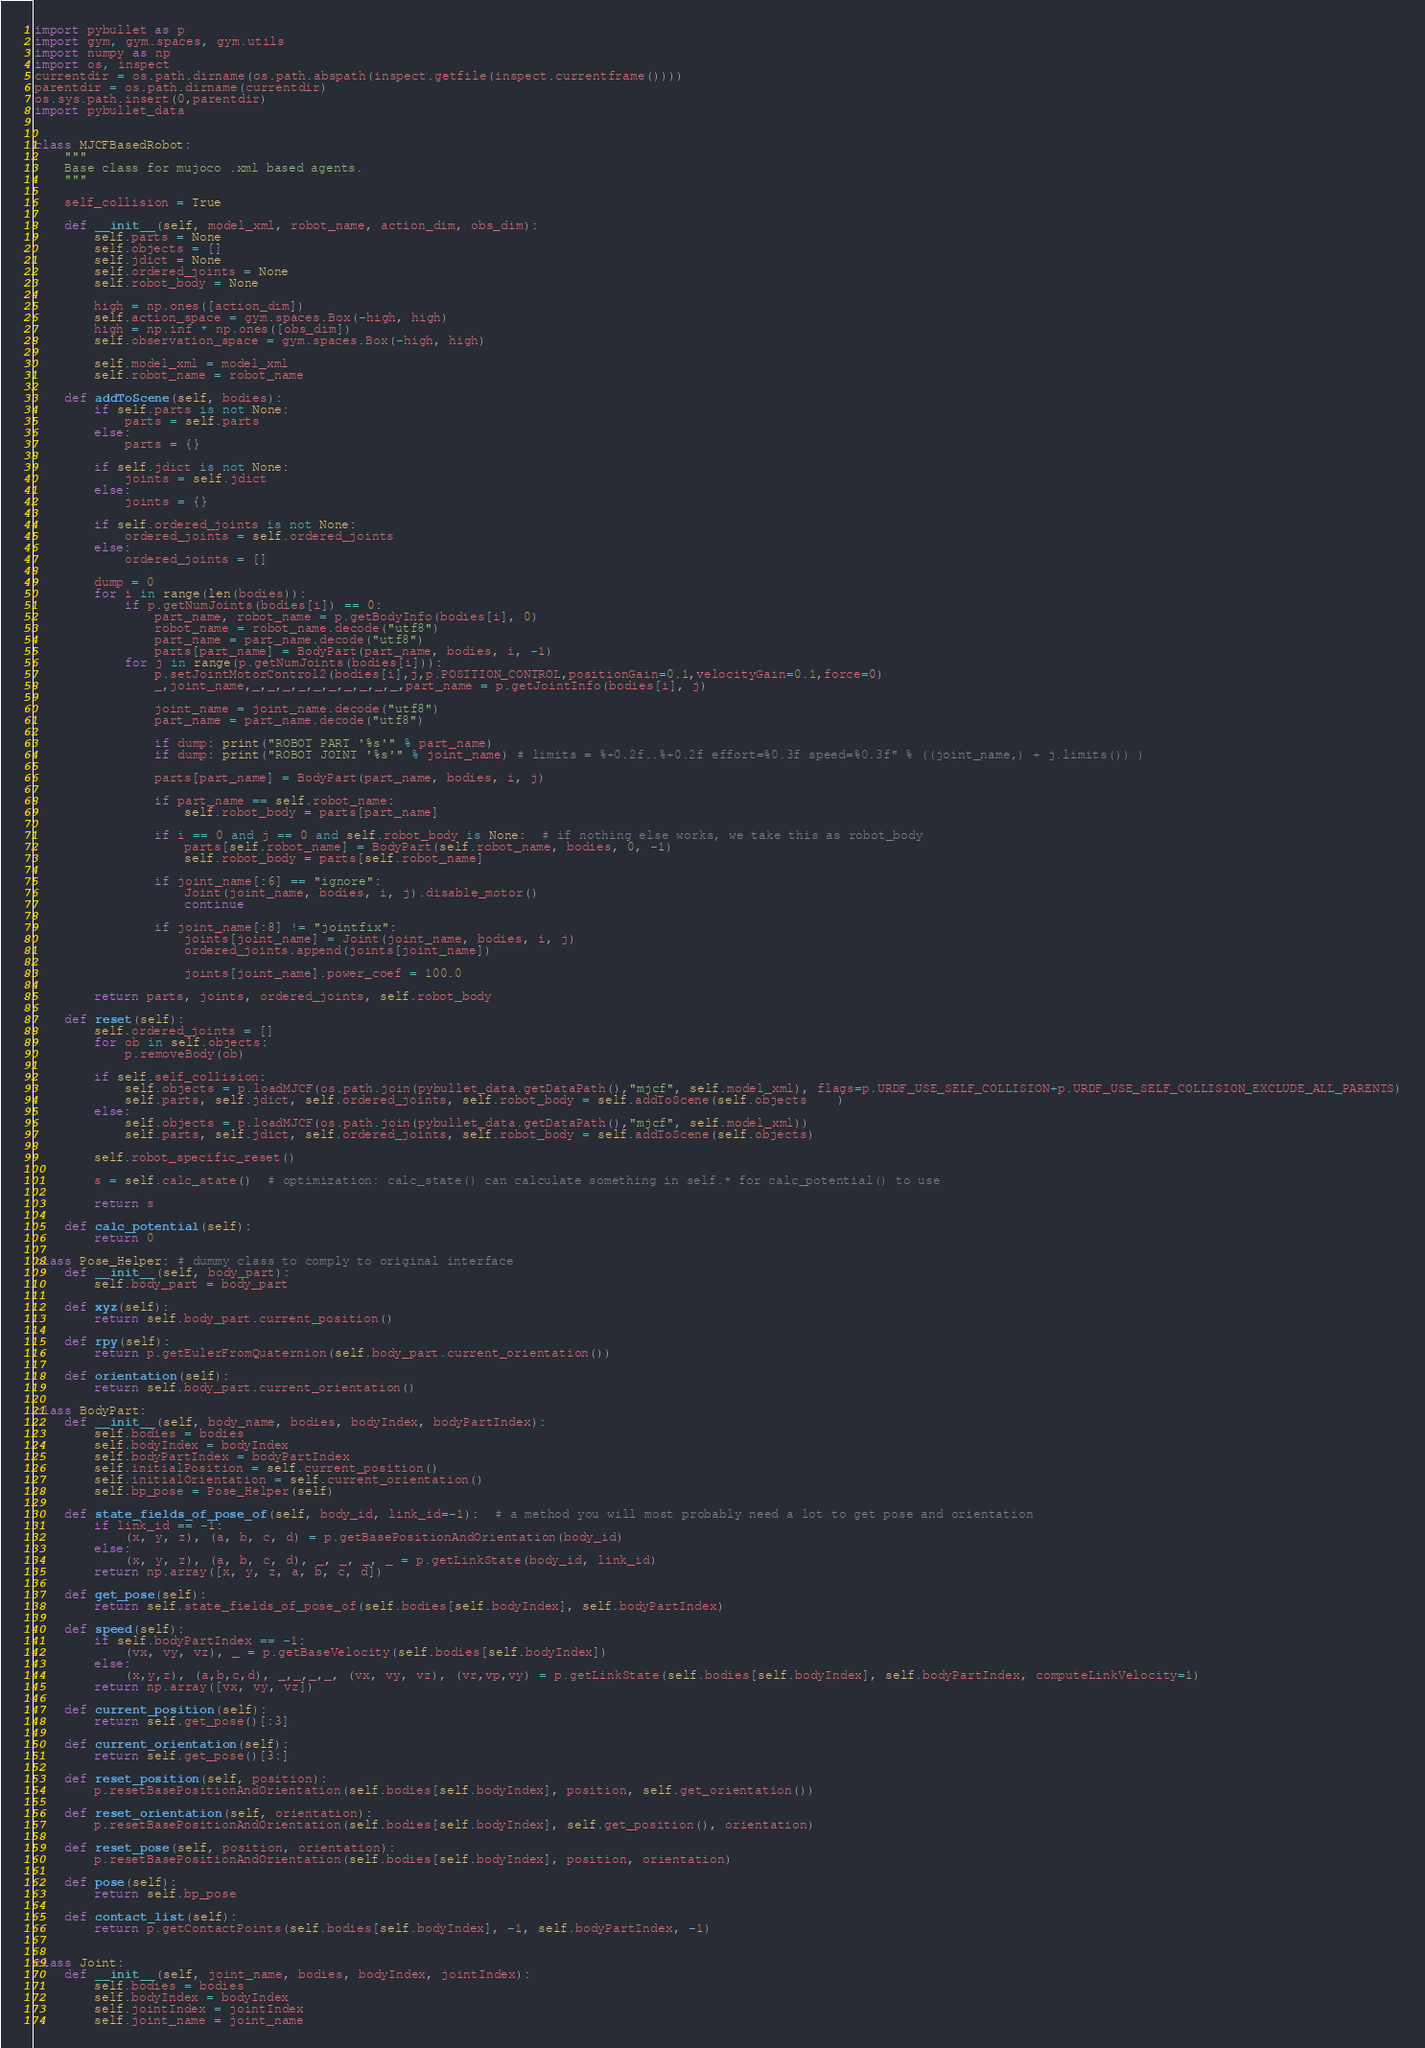Convert code to text. <code><loc_0><loc_0><loc_500><loc_500><_Python_>import pybullet as p
import gym, gym.spaces, gym.utils
import numpy as np
import os, inspect
currentdir = os.path.dirname(os.path.abspath(inspect.getfile(inspect.currentframe())))
parentdir = os.path.dirname(currentdir)
os.sys.path.insert(0,parentdir)
import pybullet_data


class MJCFBasedRobot:
	"""
	Base class for mujoco .xml based agents.
	"""

	self_collision = True

	def __init__(self, model_xml, robot_name, action_dim, obs_dim):
		self.parts = None
		self.objects = []
		self.jdict = None
		self.ordered_joints = None
		self.robot_body = None

		high = np.ones([action_dim])
		self.action_space = gym.spaces.Box(-high, high)
		high = np.inf * np.ones([obs_dim])
		self.observation_space = gym.spaces.Box(-high, high)

		self.model_xml = model_xml
		self.robot_name = robot_name

	def addToScene(self, bodies):
		if self.parts is not None:
			parts = self.parts
		else:
			parts = {}

		if self.jdict is not None:
			joints = self.jdict
		else:
			joints = {}

		if self.ordered_joints is not None:
			ordered_joints = self.ordered_joints
		else:
			ordered_joints = []

		dump = 0
		for i in range(len(bodies)):
			if p.getNumJoints(bodies[i]) == 0:
				part_name, robot_name = p.getBodyInfo(bodies[i], 0)
				robot_name = robot_name.decode("utf8")
				part_name = part_name.decode("utf8")
				parts[part_name] = BodyPart(part_name, bodies, i, -1)
			for j in range(p.getNumJoints(bodies[i])):
				p.setJointMotorControl2(bodies[i],j,p.POSITION_CONTROL,positionGain=0.1,velocityGain=0.1,force=0)
				_,joint_name,_,_,_,_,_,_,_,_,_,_,part_name = p.getJointInfo(bodies[i], j)

				joint_name = joint_name.decode("utf8")
				part_name = part_name.decode("utf8")

				if dump: print("ROBOT PART '%s'" % part_name)
				if dump: print("ROBOT JOINT '%s'" % joint_name) # limits = %+0.2f..%+0.2f effort=%0.3f speed=%0.3f" % ((joint_name,) + j.limits()) )

				parts[part_name] = BodyPart(part_name, bodies, i, j)

				if part_name == self.robot_name:
					self.robot_body = parts[part_name]

				if i == 0 and j == 0 and self.robot_body is None:  # if nothing else works, we take this as robot_body
					parts[self.robot_name] = BodyPart(self.robot_name, bodies, 0, -1)
					self.robot_body = parts[self.robot_name]

				if joint_name[:6] == "ignore":
					Joint(joint_name, bodies, i, j).disable_motor()
					continue

				if joint_name[:8] != "jointfix":
					joints[joint_name] = Joint(joint_name, bodies, i, j)
					ordered_joints.append(joints[joint_name])

					joints[joint_name].power_coef = 100.0

		return parts, joints, ordered_joints, self.robot_body

	def reset(self):
		self.ordered_joints = []
		for ob in self.objects:
			p.removeBody(ob)
		
		if self.self_collision:
			self.objects = p.loadMJCF(os.path.join(pybullet_data.getDataPath(),"mjcf", self.model_xml), flags=p.URDF_USE_SELF_COLLISION+p.URDF_USE_SELF_COLLISION_EXCLUDE_ALL_PARENTS)
			self.parts, self.jdict, self.ordered_joints, self.robot_body = self.addToScene(self.objects	)
		else:
			self.objects = p.loadMJCF(os.path.join(pybullet_data.getDataPath(),"mjcf", self.model_xml))
			self.parts, self.jdict, self.ordered_joints, self.robot_body = self.addToScene(self.objects)

		self.robot_specific_reset()

		s = self.calc_state()  # optimization: calc_state() can calculate something in self.* for calc_potential() to use

		return s

	def calc_potential(self):
		return 0

class Pose_Helper: # dummy class to comply to original interface
	def __init__(self, body_part):
		self.body_part = body_part

	def xyz(self):
		return self.body_part.current_position()

	def rpy(self):
		return p.getEulerFromQuaternion(self.body_part.current_orientation())

	def orientation(self):
		return self.body_part.current_orientation()

class BodyPart:
	def __init__(self, body_name, bodies, bodyIndex, bodyPartIndex):
		self.bodies = bodies
		self.bodyIndex = bodyIndex
		self.bodyPartIndex = bodyPartIndex
		self.initialPosition = self.current_position()
		self.initialOrientation = self.current_orientation()
		self.bp_pose = Pose_Helper(self)

	def state_fields_of_pose_of(self, body_id, link_id=-1):  # a method you will most probably need a lot to get pose and orientation
		if link_id == -1:
			(x, y, z), (a, b, c, d) = p.getBasePositionAndOrientation(body_id)
		else:
			(x, y, z), (a, b, c, d), _, _, _, _ = p.getLinkState(body_id, link_id)
		return np.array([x, y, z, a, b, c, d])

	def get_pose(self):
		return self.state_fields_of_pose_of(self.bodies[self.bodyIndex], self.bodyPartIndex)

	def speed(self):
		if self.bodyPartIndex == -1:
			(vx, vy, vz), _ = p.getBaseVelocity(self.bodies[self.bodyIndex])
		else:
			(x,y,z), (a,b,c,d), _,_,_,_, (vx, vy, vz), (vr,vp,vy) = p.getLinkState(self.bodies[self.bodyIndex], self.bodyPartIndex, computeLinkVelocity=1)
		return np.array([vx, vy, vz])

	def current_position(self):
		return self.get_pose()[:3]

	def current_orientation(self):
		return self.get_pose()[3:]

	def reset_position(self, position):
		p.resetBasePositionAndOrientation(self.bodies[self.bodyIndex], position, self.get_orientation())

	def reset_orientation(self, orientation):
		p.resetBasePositionAndOrientation(self.bodies[self.bodyIndex], self.get_position(), orientation)

	def reset_pose(self, position, orientation):
		p.resetBasePositionAndOrientation(self.bodies[self.bodyIndex], position, orientation)

	def pose(self):
		return self.bp_pose

	def contact_list(self):
		return p.getContactPoints(self.bodies[self.bodyIndex], -1, self.bodyPartIndex, -1)


class Joint:
	def __init__(self, joint_name, bodies, bodyIndex, jointIndex):
		self.bodies = bodies
		self.bodyIndex = bodyIndex
		self.jointIndex = jointIndex
		self.joint_name = joint_name</code> 